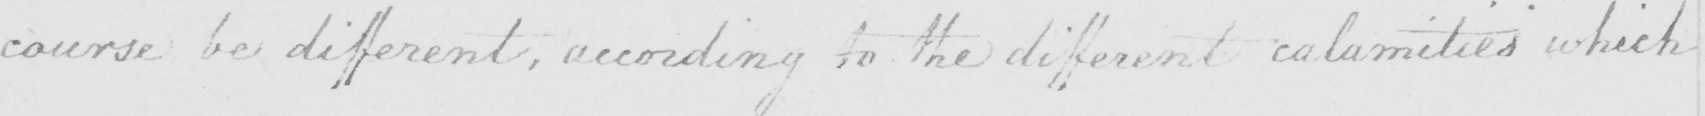Please transcribe the handwritten text in this image. course be different , according to the different calamities which 